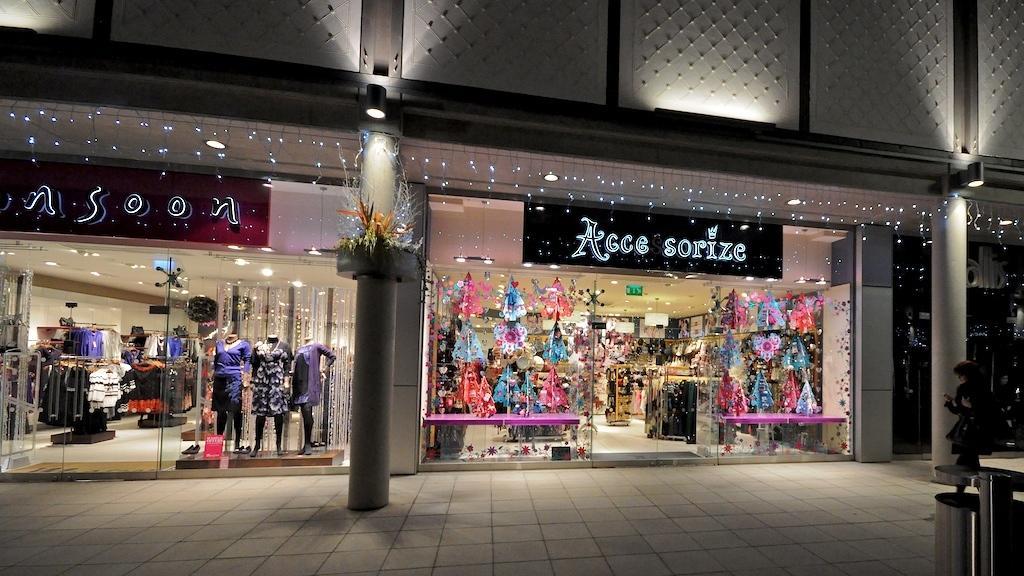In one or two sentences, can you explain what this image depicts? In the image we can see this is a building, lights, footpath, person standing, cloth shop and this is a dustbin, these are the pillars and we can see this person is wearing clothes. 